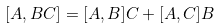<formula> <loc_0><loc_0><loc_500><loc_500>[ A , B C ] = [ A , B ] C + [ A , C ] B</formula> 